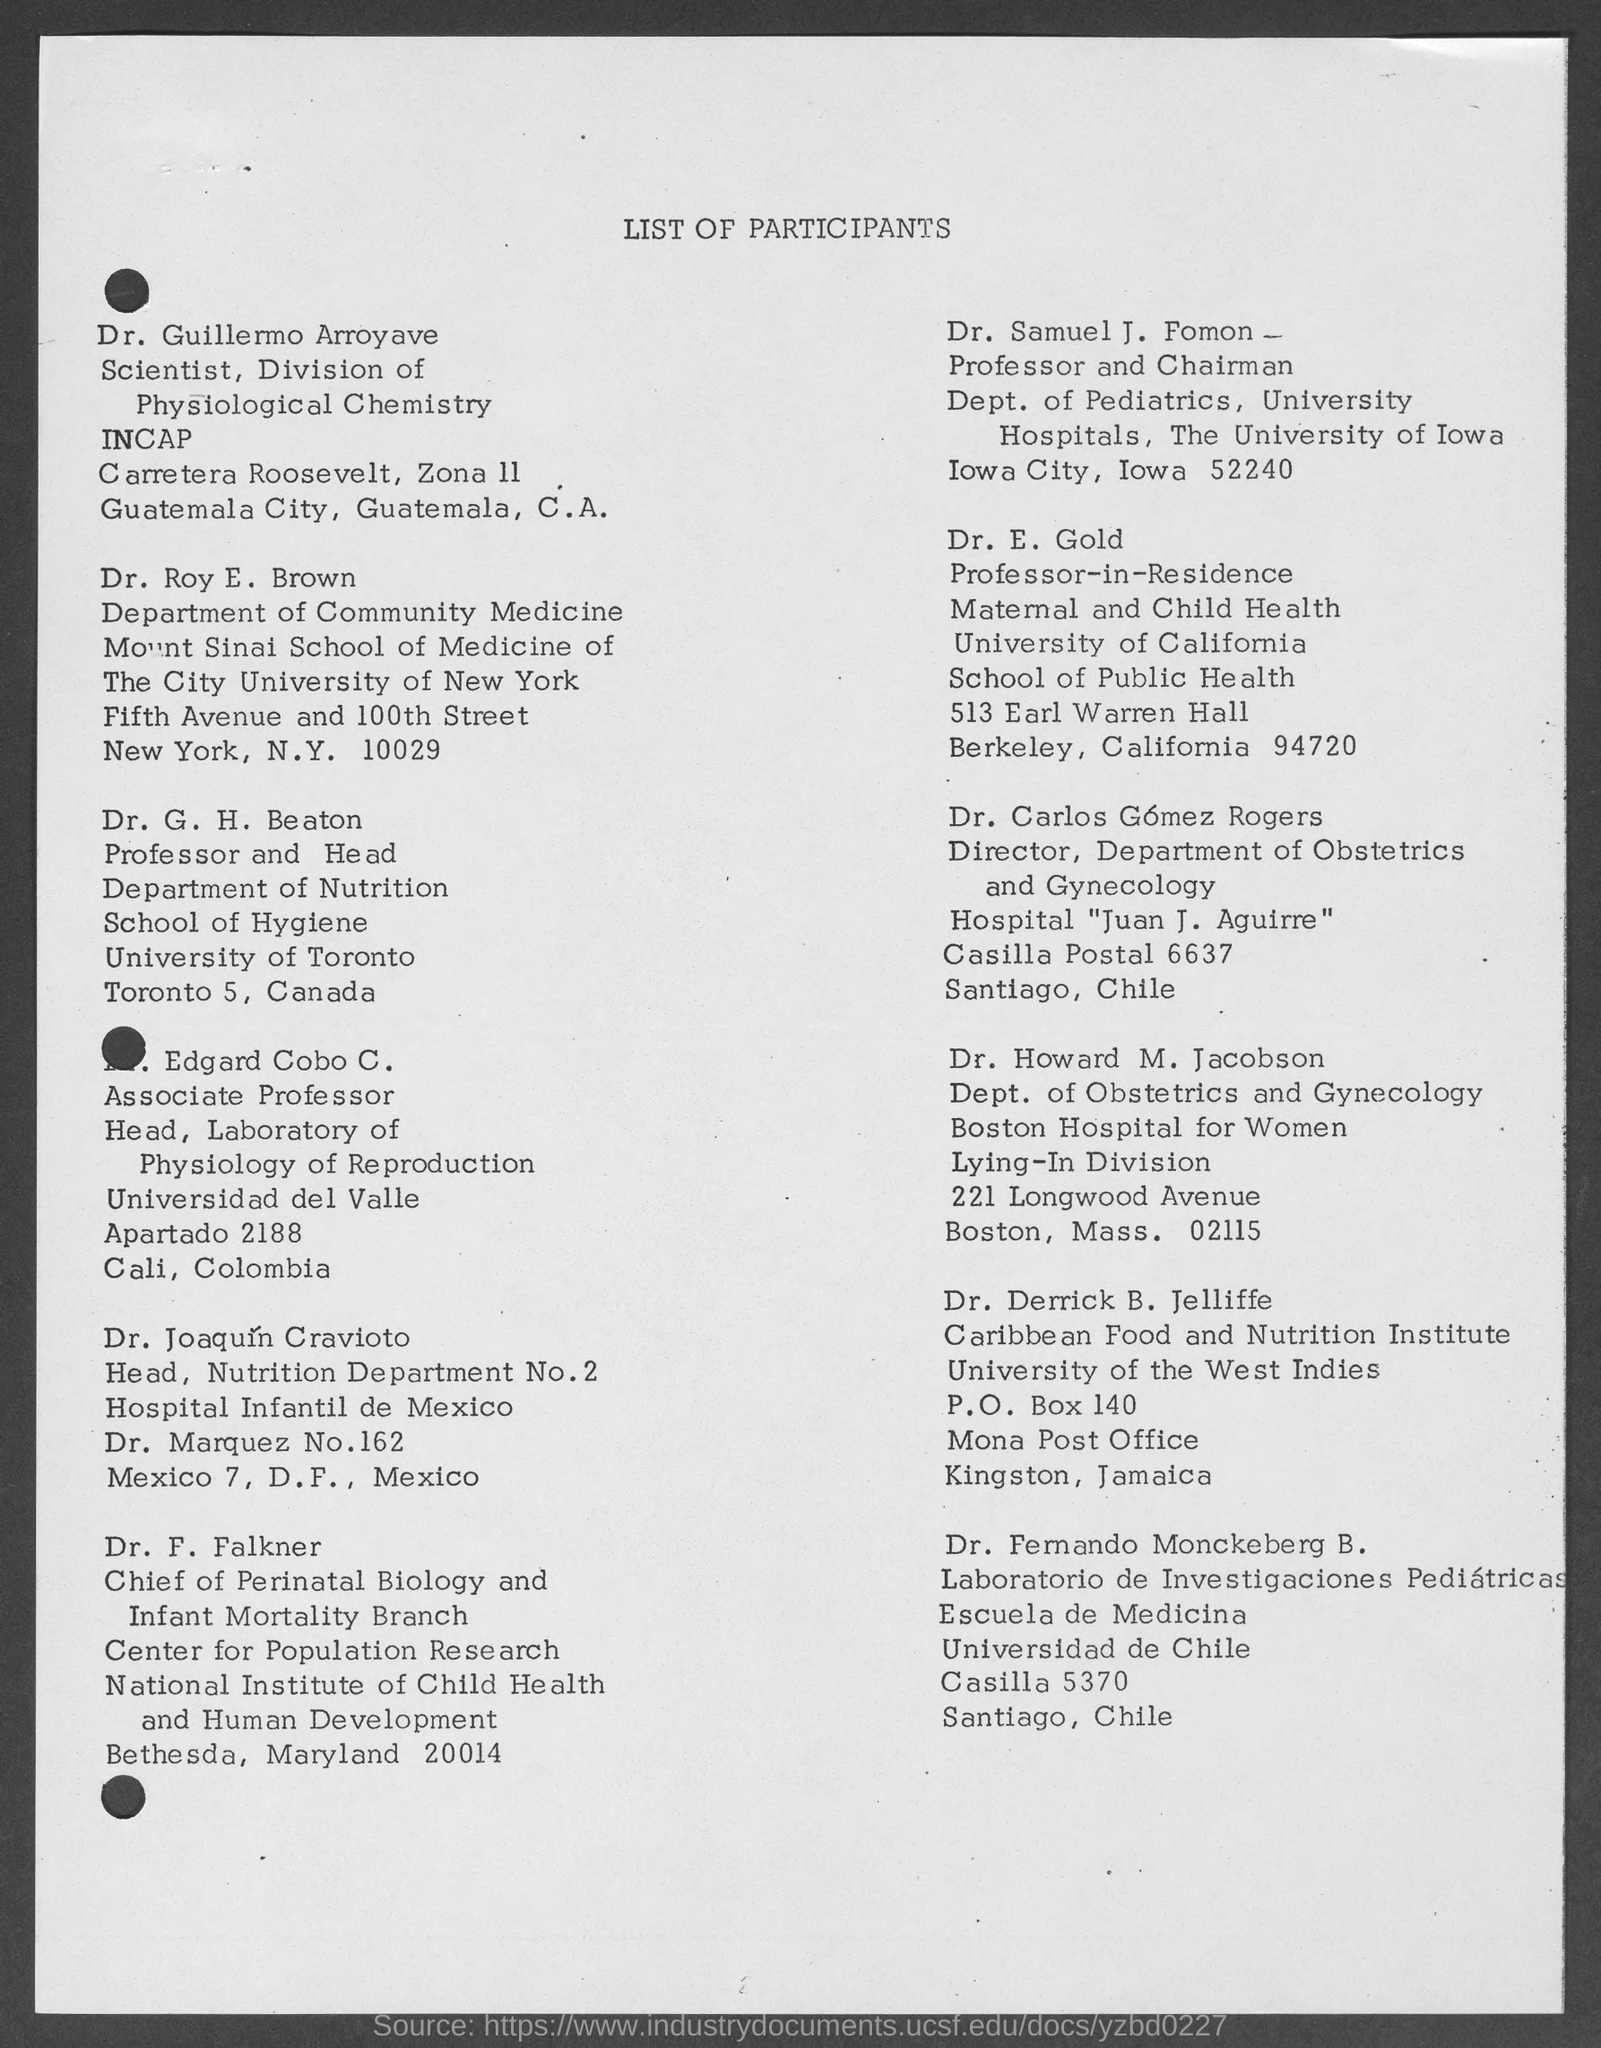Specify some key components in this picture. Dr. Derrick B. Jelliffe works at the University of the West Indies. The main title of this document is "List of participants. 